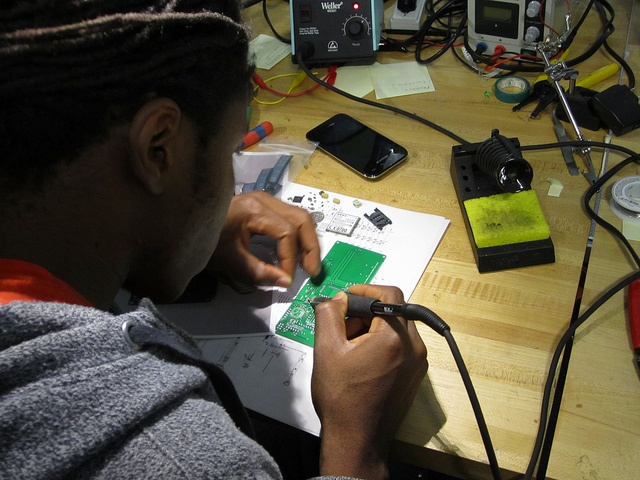Describe the objects in this image and their specific colors. I can see people in black, gray, darkgray, and maroon tones and cell phone in black, gray, and olive tones in this image. 